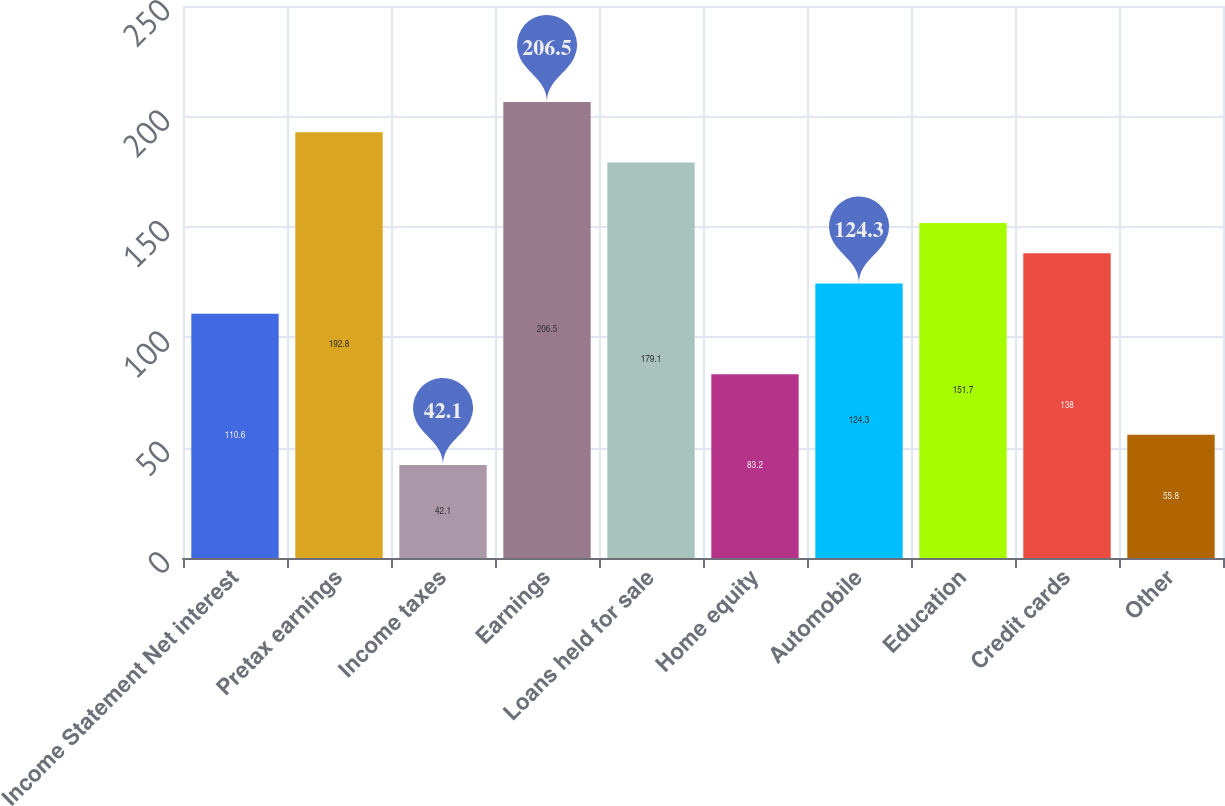Convert chart. <chart><loc_0><loc_0><loc_500><loc_500><bar_chart><fcel>Income Statement Net interest<fcel>Pretax earnings<fcel>Income taxes<fcel>Earnings<fcel>Loans held for sale<fcel>Home equity<fcel>Automobile<fcel>Education<fcel>Credit cards<fcel>Other<nl><fcel>110.6<fcel>192.8<fcel>42.1<fcel>206.5<fcel>179.1<fcel>83.2<fcel>124.3<fcel>151.7<fcel>138<fcel>55.8<nl></chart> 